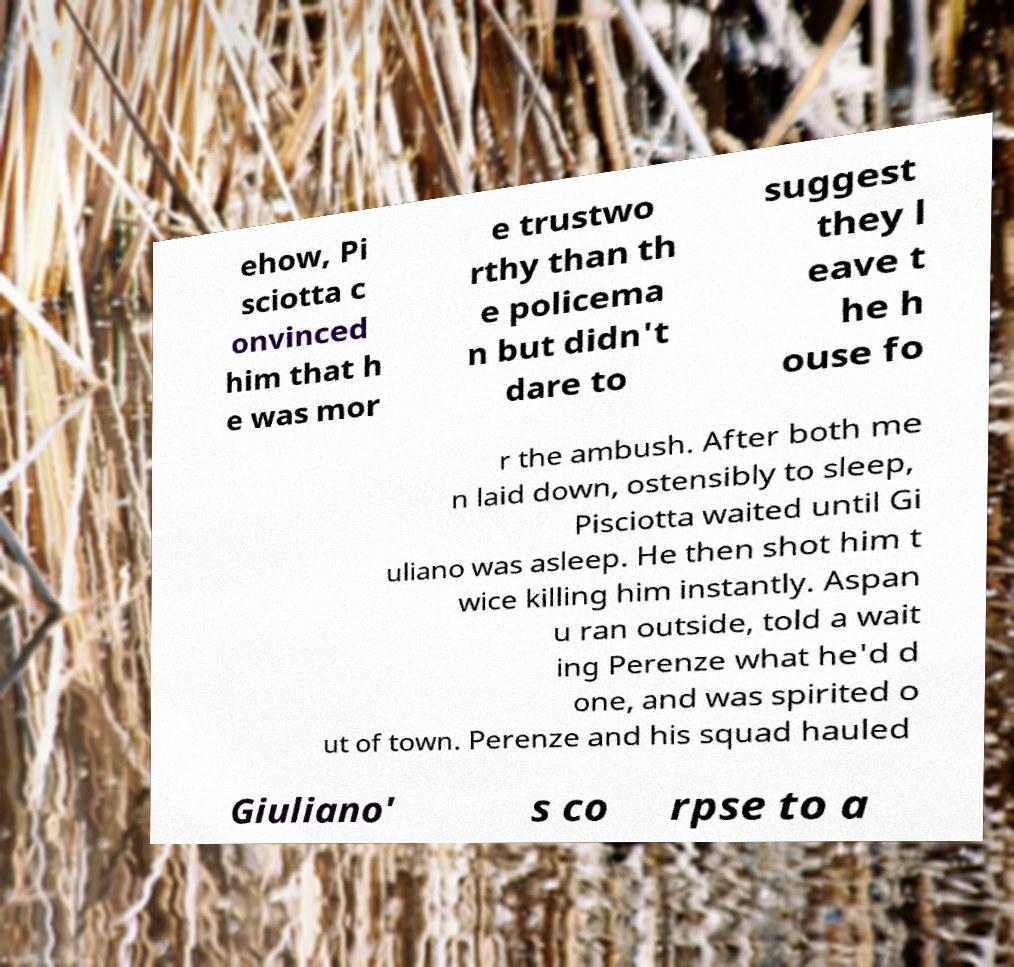I need the written content from this picture converted into text. Can you do that? ehow, Pi sciotta c onvinced him that h e was mor e trustwo rthy than th e policema n but didn't dare to suggest they l eave t he h ouse fo r the ambush. After both me n laid down, ostensibly to sleep, Pisciotta waited until Gi uliano was asleep. He then shot him t wice killing him instantly. Aspan u ran outside, told a wait ing Perenze what he'd d one, and was spirited o ut of town. Perenze and his squad hauled Giuliano' s co rpse to a 